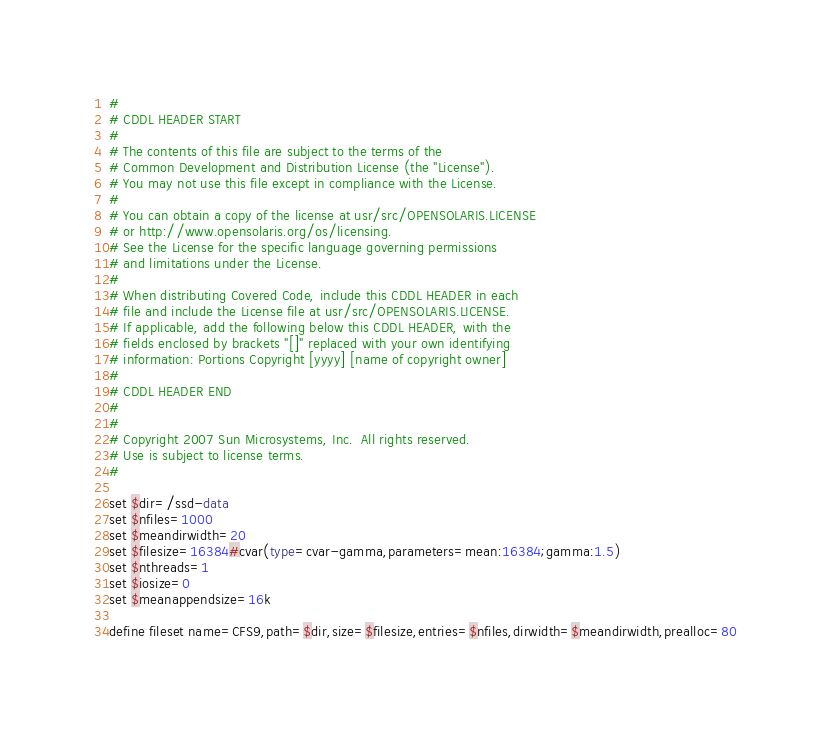<code> <loc_0><loc_0><loc_500><loc_500><_FORTRAN_>#
# CDDL HEADER START
#
# The contents of this file are subject to the terms of the
# Common Development and Distribution License (the "License").
# You may not use this file except in compliance with the License.
#
# You can obtain a copy of the license at usr/src/OPENSOLARIS.LICENSE
# or http://www.opensolaris.org/os/licensing.
# See the License for the specific language governing permissions
# and limitations under the License.
#
# When distributing Covered Code, include this CDDL HEADER in each
# file and include the License file at usr/src/OPENSOLARIS.LICENSE.
# If applicable, add the following below this CDDL HEADER, with the
# fields enclosed by brackets "[]" replaced with your own identifying
# information: Portions Copyright [yyyy] [name of copyright owner]
#
# CDDL HEADER END
#
#
# Copyright 2007 Sun Microsystems, Inc.  All rights reserved.
# Use is subject to license terms.
#

set $dir=/ssd-data
set $nfiles=1000
set $meandirwidth=20
set $filesize=16384#cvar(type=cvar-gamma,parameters=mean:16384;gamma:1.5)
set $nthreads=1
set $iosize=0
set $meanappendsize=16k

define fileset name=CFS9,path=$dir,size=$filesize,entries=$nfiles,dirwidth=$meandirwidth,prealloc=80</code> 